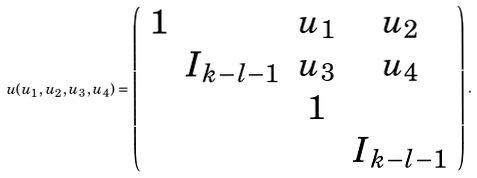<formula> <loc_0><loc_0><loc_500><loc_500>u ( u _ { 1 } , u _ { 2 } , u _ { 3 } , u _ { 4 } ) = \left ( \begin{array} { c c c c } 1 & & u _ { 1 } & u _ { 2 } \\ & I _ { k - l - 1 } & u _ { 3 } & u _ { 4 } \\ & & 1 \\ & & & I _ { k - l - 1 } \end{array} \right ) .</formula> 